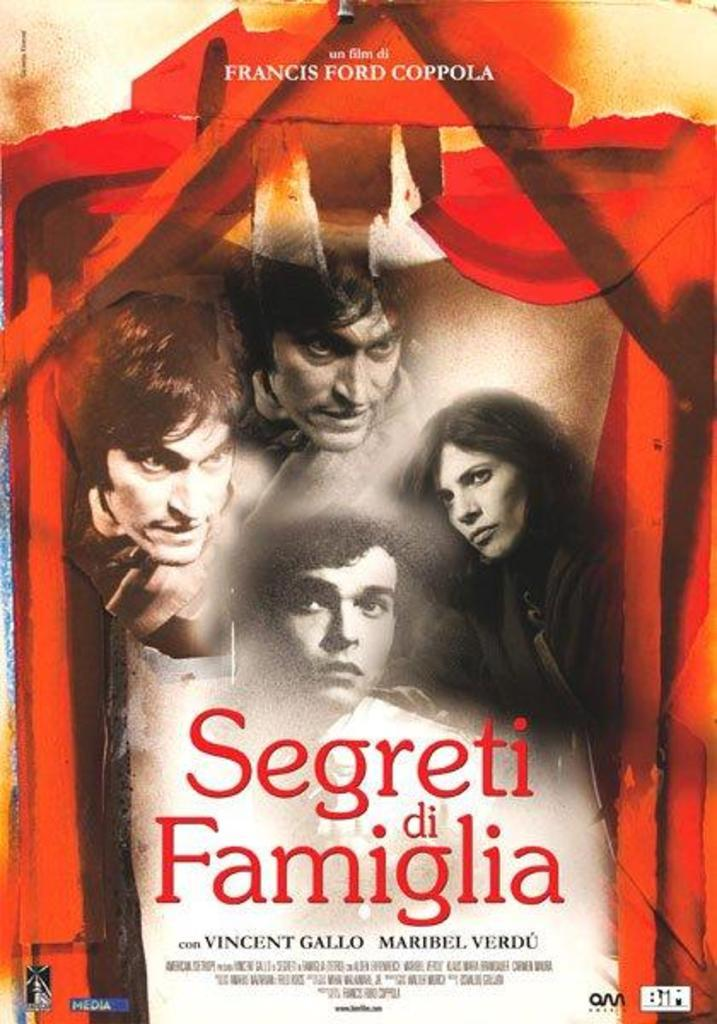Provide a one-sentence caption for the provided image. Four people look off into the distance on a movie poster for Segreti di Famiglia. 